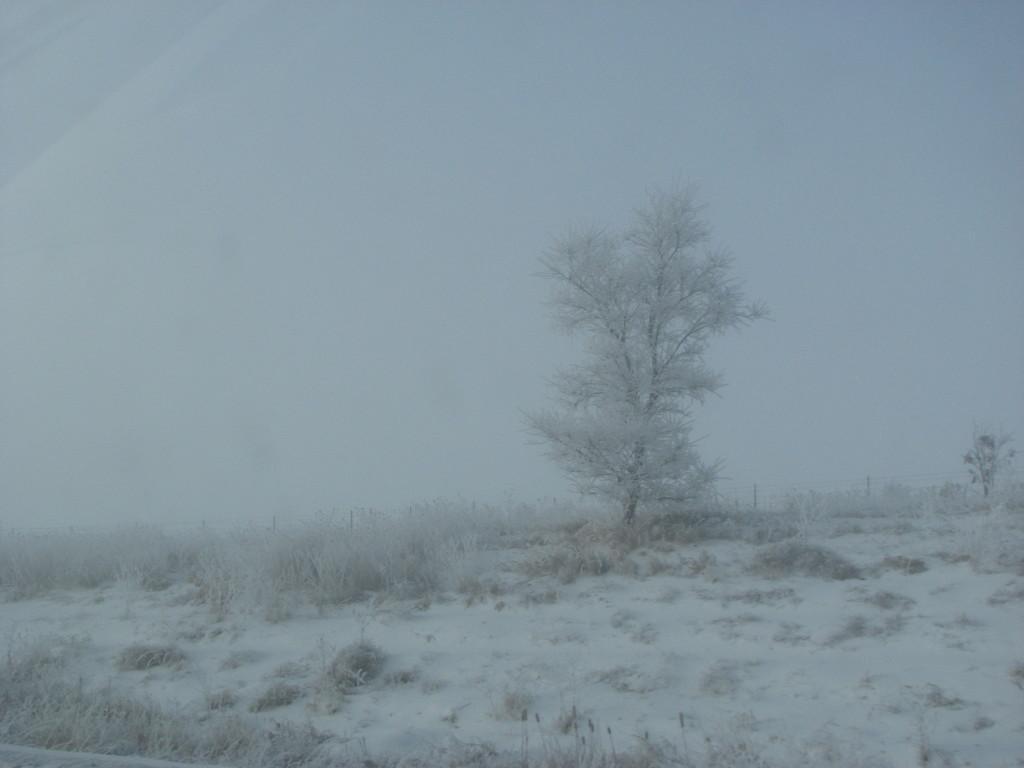How would you summarize this image in a sentence or two? We can see snow,grass and trees. In the background we can see fence and sky. 